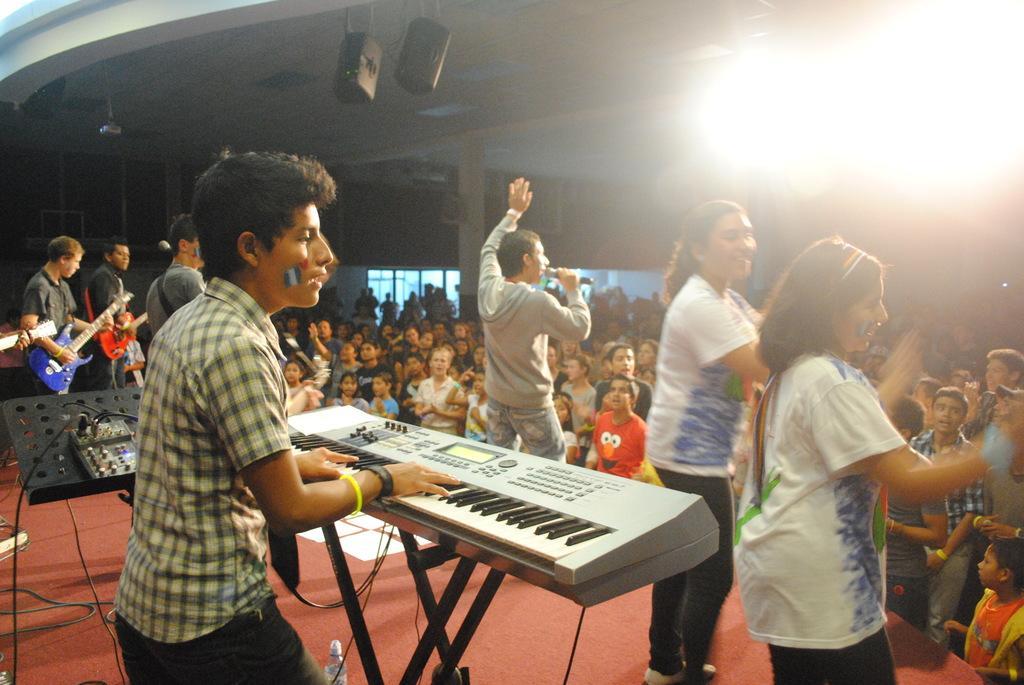Could you give a brief overview of what you see in this image? In this image there are group of people standing. In front the person is playing the piano. 